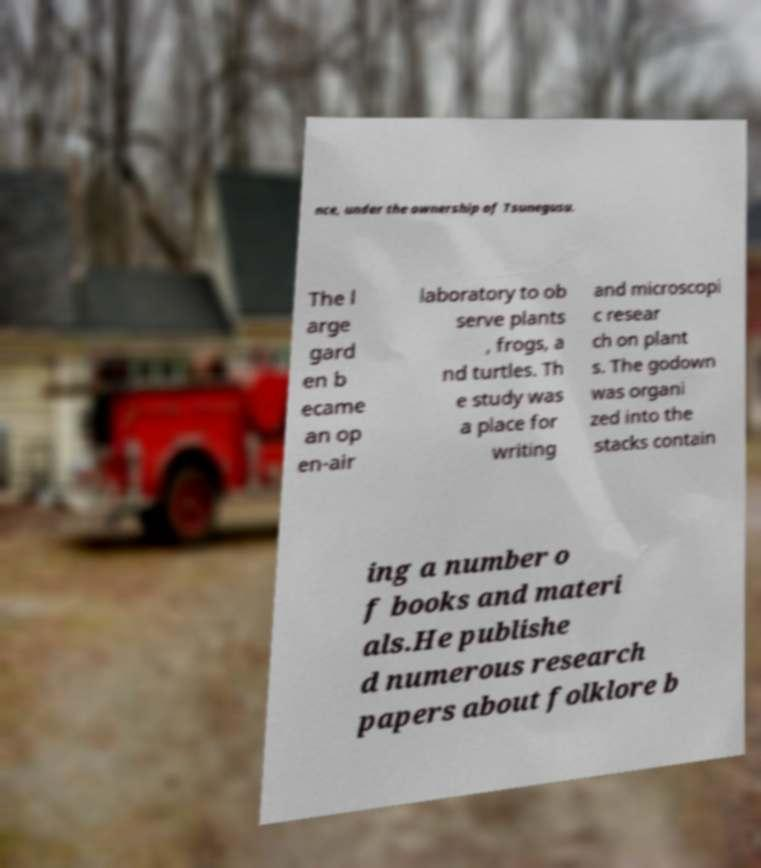Please read and relay the text visible in this image. What does it say? nce, under the ownership of Tsunegusu. The l arge gard en b ecame an op en-air laboratory to ob serve plants , frogs, a nd turtles. Th e study was a place for writing and microscopi c resear ch on plant s. The godown was organi zed into the stacks contain ing a number o f books and materi als.He publishe d numerous research papers about folklore b 